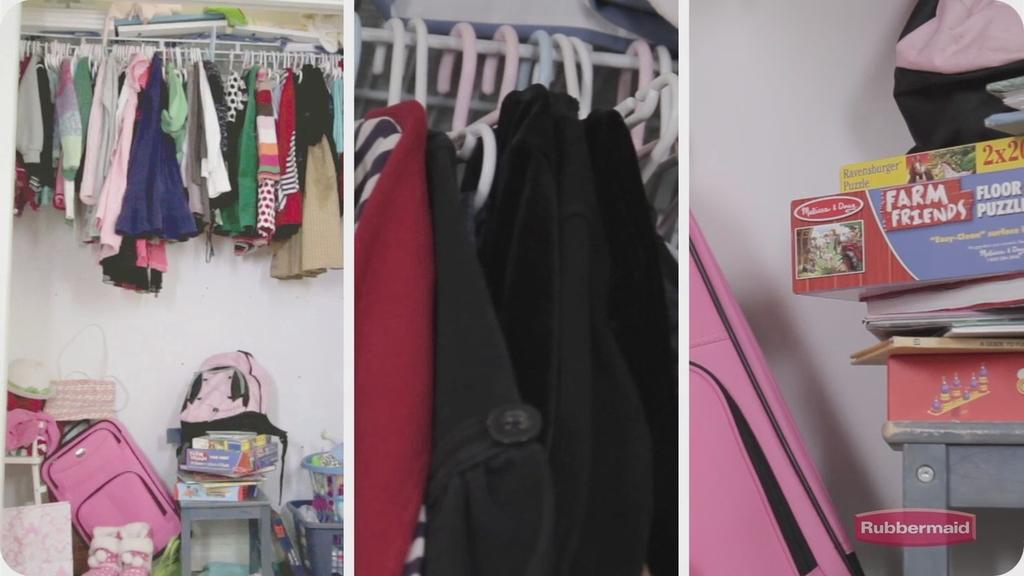<image>
Relay a brief, clear account of the picture shown. A closet includes a Farm Friends floor puzzle. 